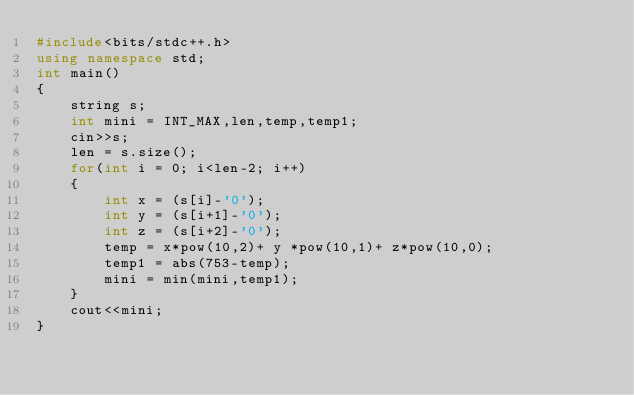Convert code to text. <code><loc_0><loc_0><loc_500><loc_500><_C++_>#include<bits/stdc++.h>
using namespace std;
int main()
{
    string s;
    int mini = INT_MAX,len,temp,temp1;
    cin>>s;
    len = s.size();
    for(int i = 0; i<len-2; i++)
    {
        int x = (s[i]-'0');
        int y = (s[i+1]-'0');
        int z = (s[i+2]-'0');
        temp = x*pow(10,2)+ y *pow(10,1)+ z*pow(10,0);
        temp1 = abs(753-temp);
        mini = min(mini,temp1);
    }
    cout<<mini;
}
</code> 